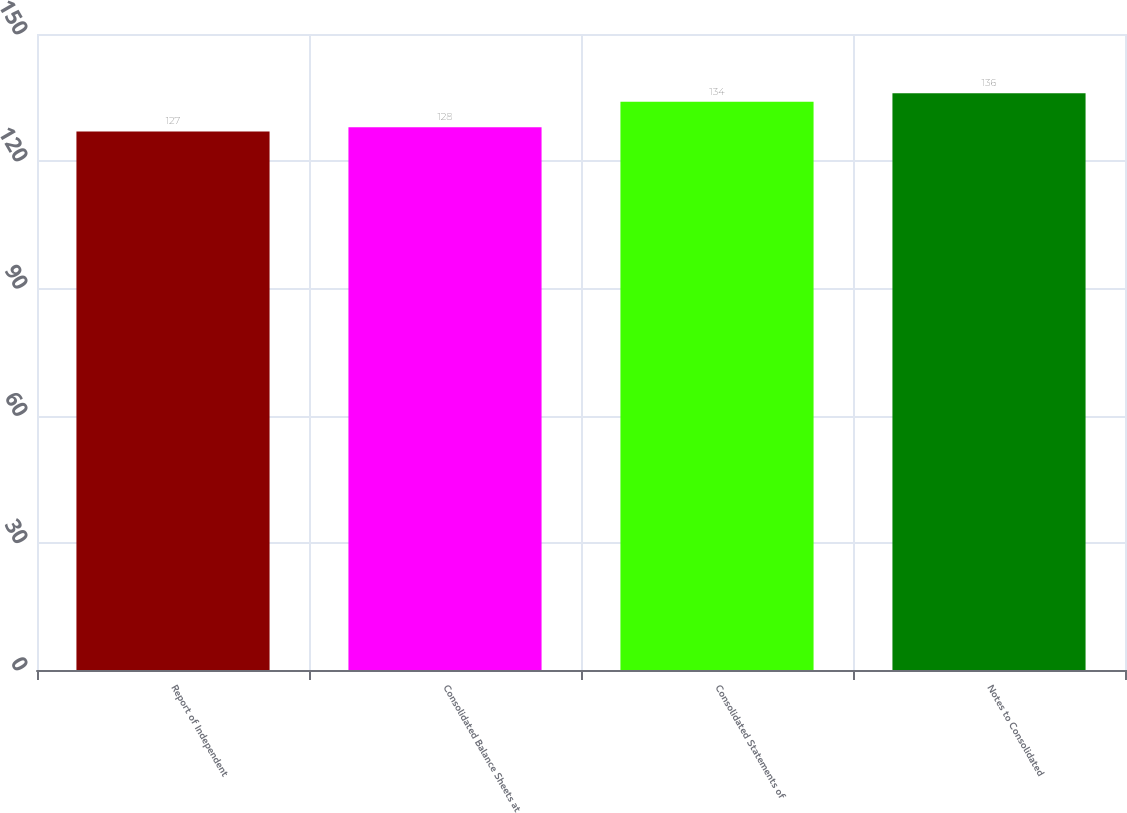Convert chart to OTSL. <chart><loc_0><loc_0><loc_500><loc_500><bar_chart><fcel>Report of Independent<fcel>Consolidated Balance Sheets at<fcel>Consolidated Statements of<fcel>Notes to Consolidated<nl><fcel>127<fcel>128<fcel>134<fcel>136<nl></chart> 